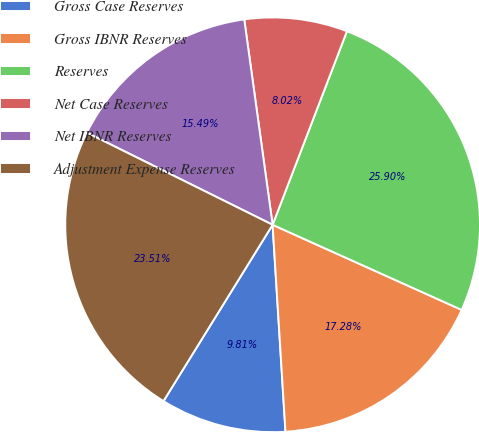Convert chart. <chart><loc_0><loc_0><loc_500><loc_500><pie_chart><fcel>Gross Case Reserves<fcel>Gross IBNR Reserves<fcel>Reserves<fcel>Net Case Reserves<fcel>Net IBNR Reserves<fcel>Adjustment Expense Reserves<nl><fcel>9.81%<fcel>17.28%<fcel>25.9%<fcel>8.02%<fcel>15.49%<fcel>23.51%<nl></chart> 